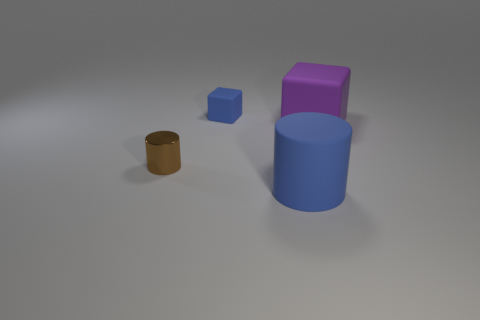Can you infer the sizes of these objects relative to one another? The objects vary in size. The cylinder is the largest, followed by the metallic-looking object, and the smallest appears to be the blue block. Their relative sizes can be inferred by their proportions and the shadows they cast on the surface indicating their relative heights. 